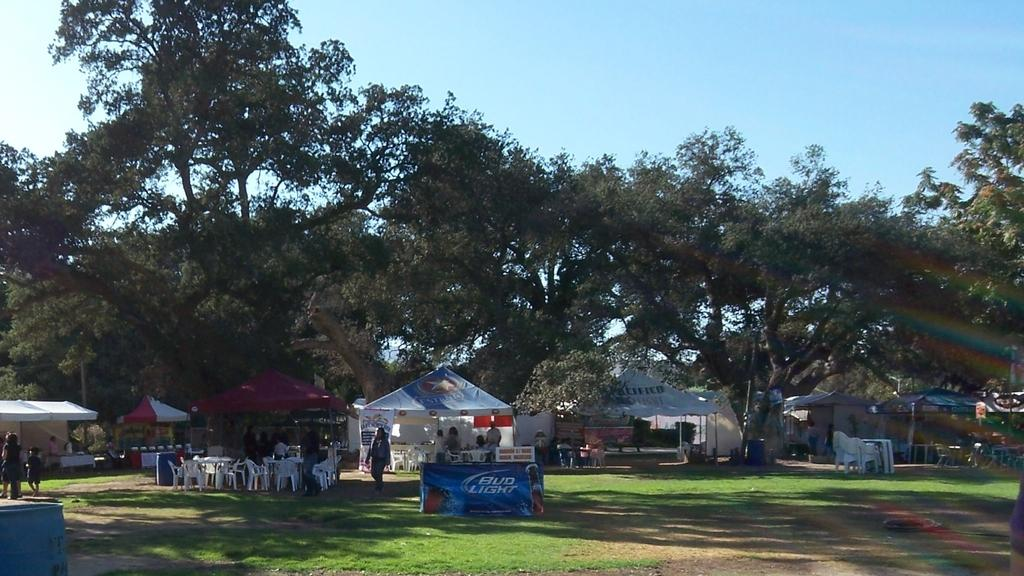What type of temporary shelters can be seen in the image? There are tents in the image. What type of furniture is visible in the image? There are chairs and tables in the image. What are the people in the image doing? There are people walking on the grass in the image. What type of vegetation is visible in the image? There are trees visible in the image. Who is serving breakfast to the people in the image? There is no mention of breakfast or a servant in the image. What type of terrain is visible in the image? The image does not show any slope or specific terrain features; it only shows grass and trees. 